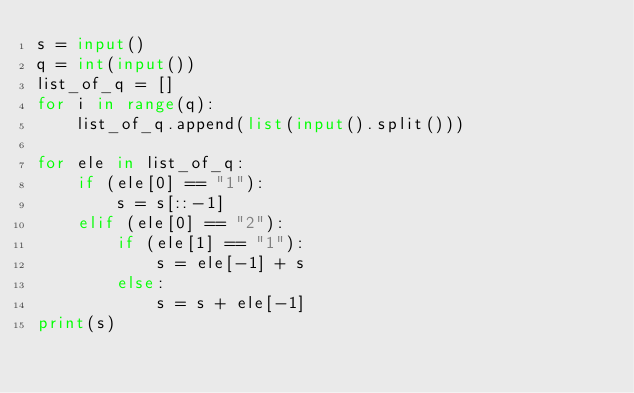Convert code to text. <code><loc_0><loc_0><loc_500><loc_500><_Python_>s = input()
q = int(input())
list_of_q = []
for i in range(q):
    list_of_q.append(list(input().split()))

for ele in list_of_q:
    if (ele[0] == "1"):
        s = s[::-1]
    elif (ele[0] == "2"):
        if (ele[1] == "1"):
            s = ele[-1] + s
        else:
            s = s + ele[-1]
print(s)
</code> 